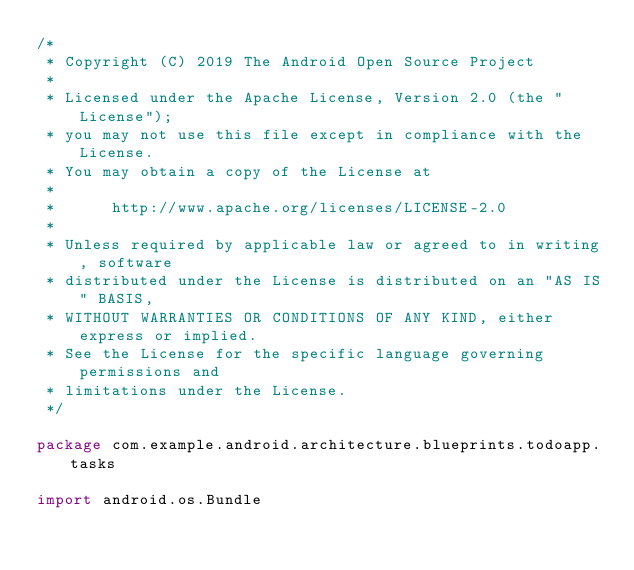<code> <loc_0><loc_0><loc_500><loc_500><_Kotlin_>/*
 * Copyright (C) 2019 The Android Open Source Project
 *
 * Licensed under the Apache License, Version 2.0 (the "License");
 * you may not use this file except in compliance with the License.
 * You may obtain a copy of the License at
 *
 *      http://www.apache.org/licenses/LICENSE-2.0
 *
 * Unless required by applicable law or agreed to in writing, software
 * distributed under the License is distributed on an "AS IS" BASIS,
 * WITHOUT WARRANTIES OR CONDITIONS OF ANY KIND, either express or implied.
 * See the License for the specific language governing permissions and
 * limitations under the License.
 */

package com.example.android.architecture.blueprints.todoapp.tasks

import android.os.Bundle</code> 